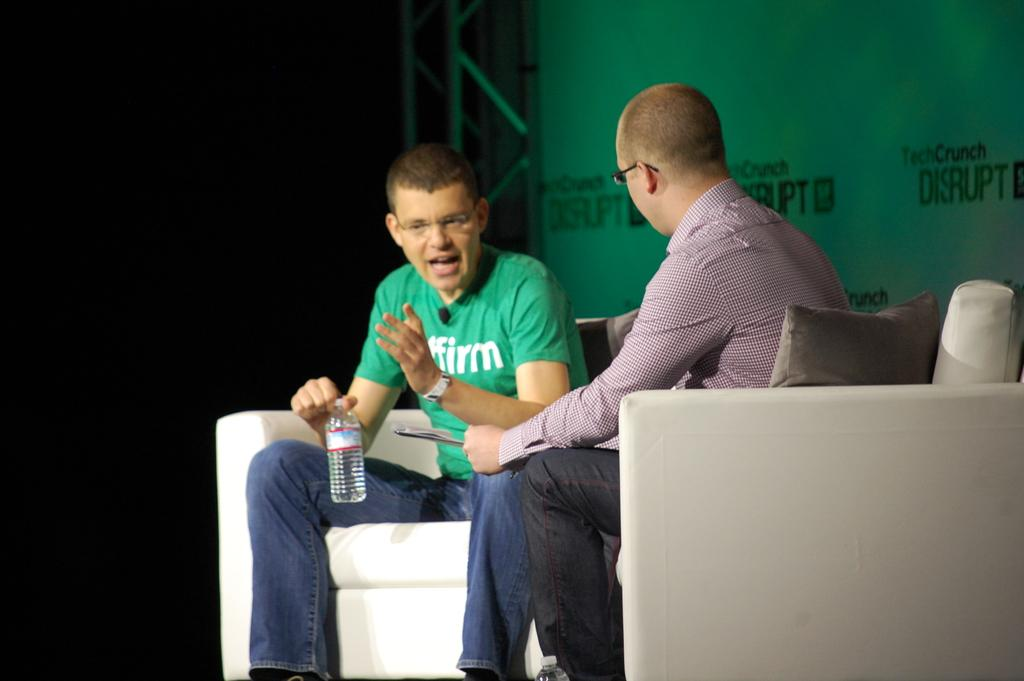How many people are sitting on the couch in the image? There are two men sitting on the couch in the image. What is the man on the left holding? The man on the left is holding a bottle. What is the man with the bottle doing? The man with the bottle is talking. What can be seen in the background of the image? There is a board and a railing visible in the background. What type of net can be seen hanging from the ceiling in the image? There is no net hanging from the ceiling in the image; it only features two men sitting on a couch, a bottle, a board, and a railing in the background. 